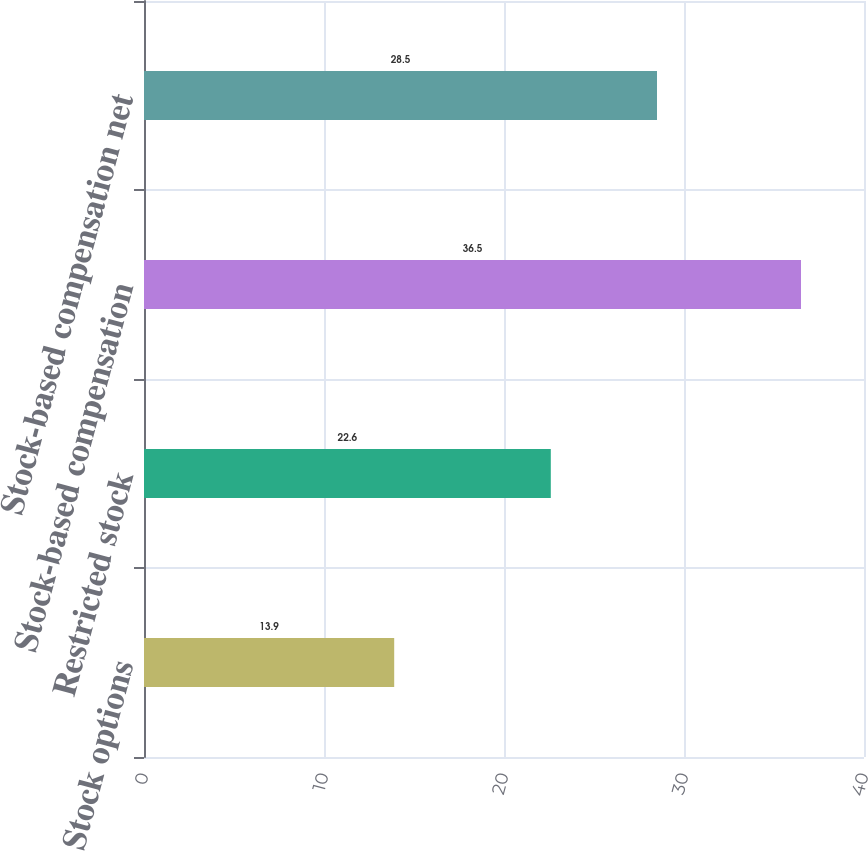Convert chart to OTSL. <chart><loc_0><loc_0><loc_500><loc_500><bar_chart><fcel>Stock options<fcel>Restricted stock<fcel>Stock-based compensation<fcel>Stock-based compensation net<nl><fcel>13.9<fcel>22.6<fcel>36.5<fcel>28.5<nl></chart> 